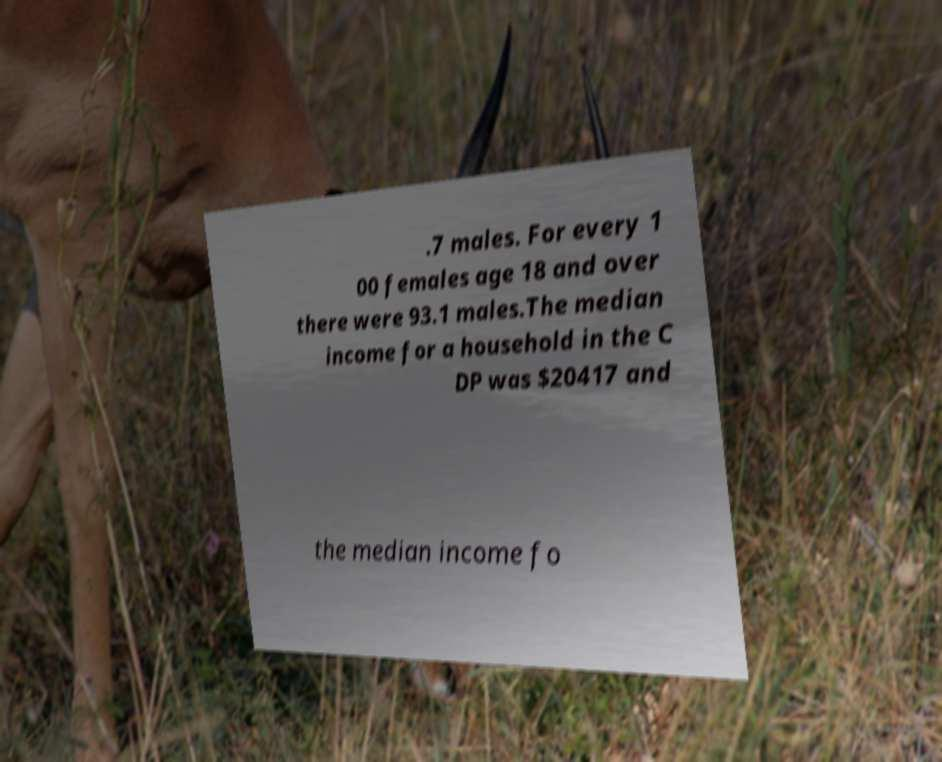Could you extract and type out the text from this image? .7 males. For every 1 00 females age 18 and over there were 93.1 males.The median income for a household in the C DP was $20417 and the median income fo 